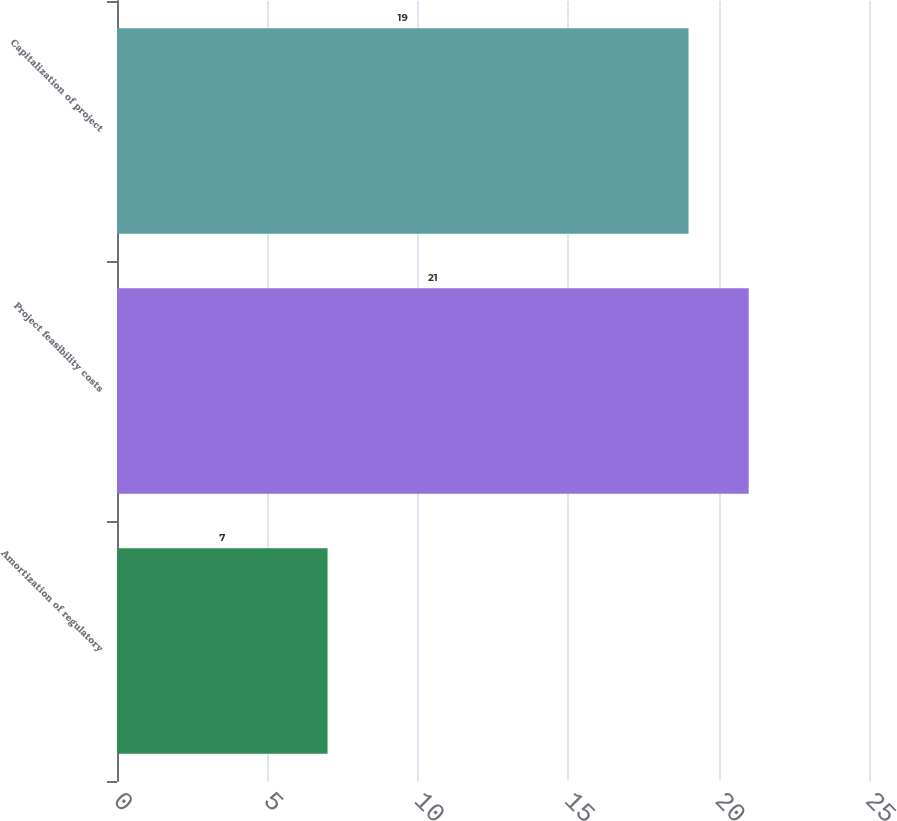Convert chart. <chart><loc_0><loc_0><loc_500><loc_500><bar_chart><fcel>Amortization of regulatory<fcel>Project feasibility costs<fcel>Capitalization of project<nl><fcel>7<fcel>21<fcel>19<nl></chart> 